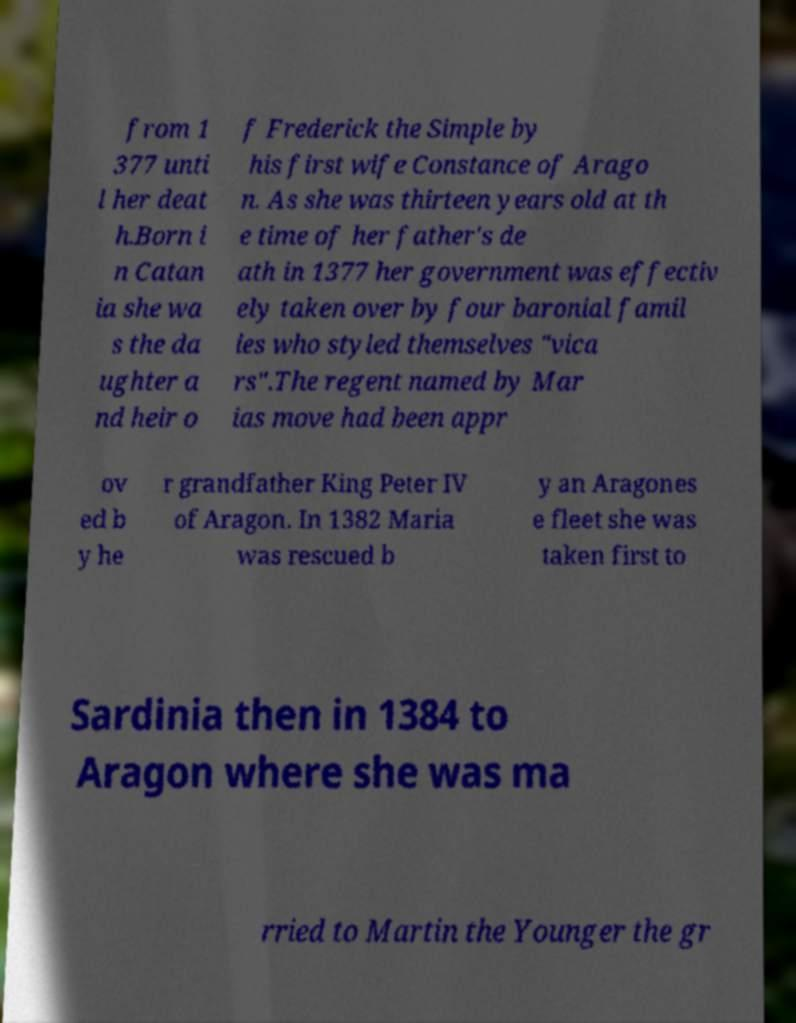Could you assist in decoding the text presented in this image and type it out clearly? from 1 377 unti l her deat h.Born i n Catan ia she wa s the da ughter a nd heir o f Frederick the Simple by his first wife Constance of Arago n. As she was thirteen years old at th e time of her father's de ath in 1377 her government was effectiv ely taken over by four baronial famil ies who styled themselves "vica rs".The regent named by Mar ias move had been appr ov ed b y he r grandfather King Peter IV of Aragon. In 1382 Maria was rescued b y an Aragones e fleet she was taken first to Sardinia then in 1384 to Aragon where she was ma rried to Martin the Younger the gr 